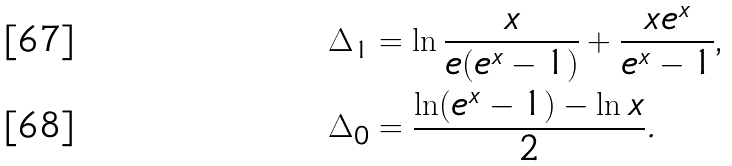Convert formula to latex. <formula><loc_0><loc_0><loc_500><loc_500>\Delta _ { 1 } & = \ln \frac { x } { e ( e ^ { x } - 1 ) } + \frac { x e ^ { x } } { e ^ { x } - 1 } \text {,} \\ \Delta _ { 0 } & = \frac { \ln ( e ^ { x } - 1 ) - \ln x } { 2 } .</formula> 